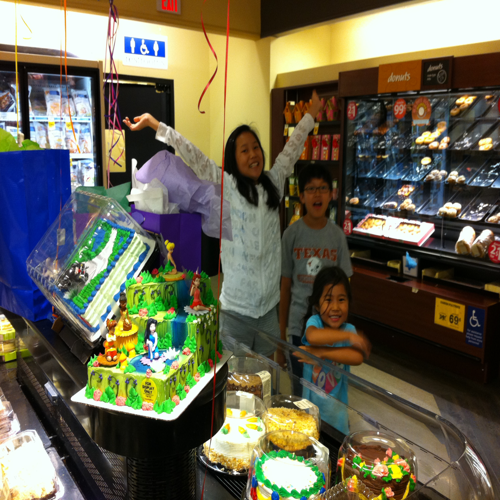What can you deduce about the setting of this image? The image seems to be taken inside a grocery store or bakery section. There are display cases with various baked goods in the background and price tags visible. The celebratory setup with a cake suggests that the store might also offer custom cake services for special occasions. 